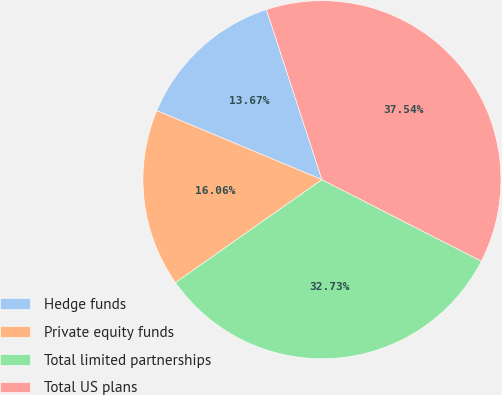Convert chart to OTSL. <chart><loc_0><loc_0><loc_500><loc_500><pie_chart><fcel>Hedge funds<fcel>Private equity funds<fcel>Total limited partnerships<fcel>Total US plans<nl><fcel>13.67%<fcel>16.06%<fcel>32.73%<fcel>37.54%<nl></chart> 